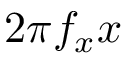Convert formula to latex. <formula><loc_0><loc_0><loc_500><loc_500>2 \pi f _ { x } x</formula> 